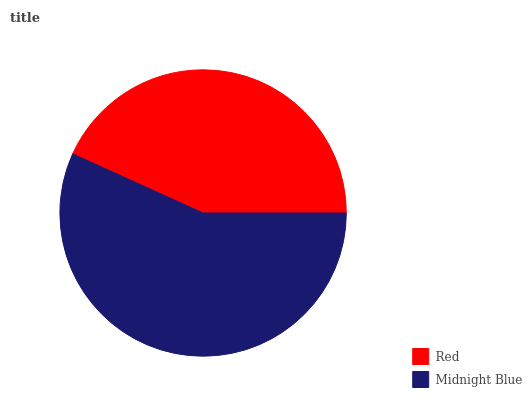Is Red the minimum?
Answer yes or no. Yes. Is Midnight Blue the maximum?
Answer yes or no. Yes. Is Midnight Blue the minimum?
Answer yes or no. No. Is Midnight Blue greater than Red?
Answer yes or no. Yes. Is Red less than Midnight Blue?
Answer yes or no. Yes. Is Red greater than Midnight Blue?
Answer yes or no. No. Is Midnight Blue less than Red?
Answer yes or no. No. Is Midnight Blue the high median?
Answer yes or no. Yes. Is Red the low median?
Answer yes or no. Yes. Is Red the high median?
Answer yes or no. No. Is Midnight Blue the low median?
Answer yes or no. No. 